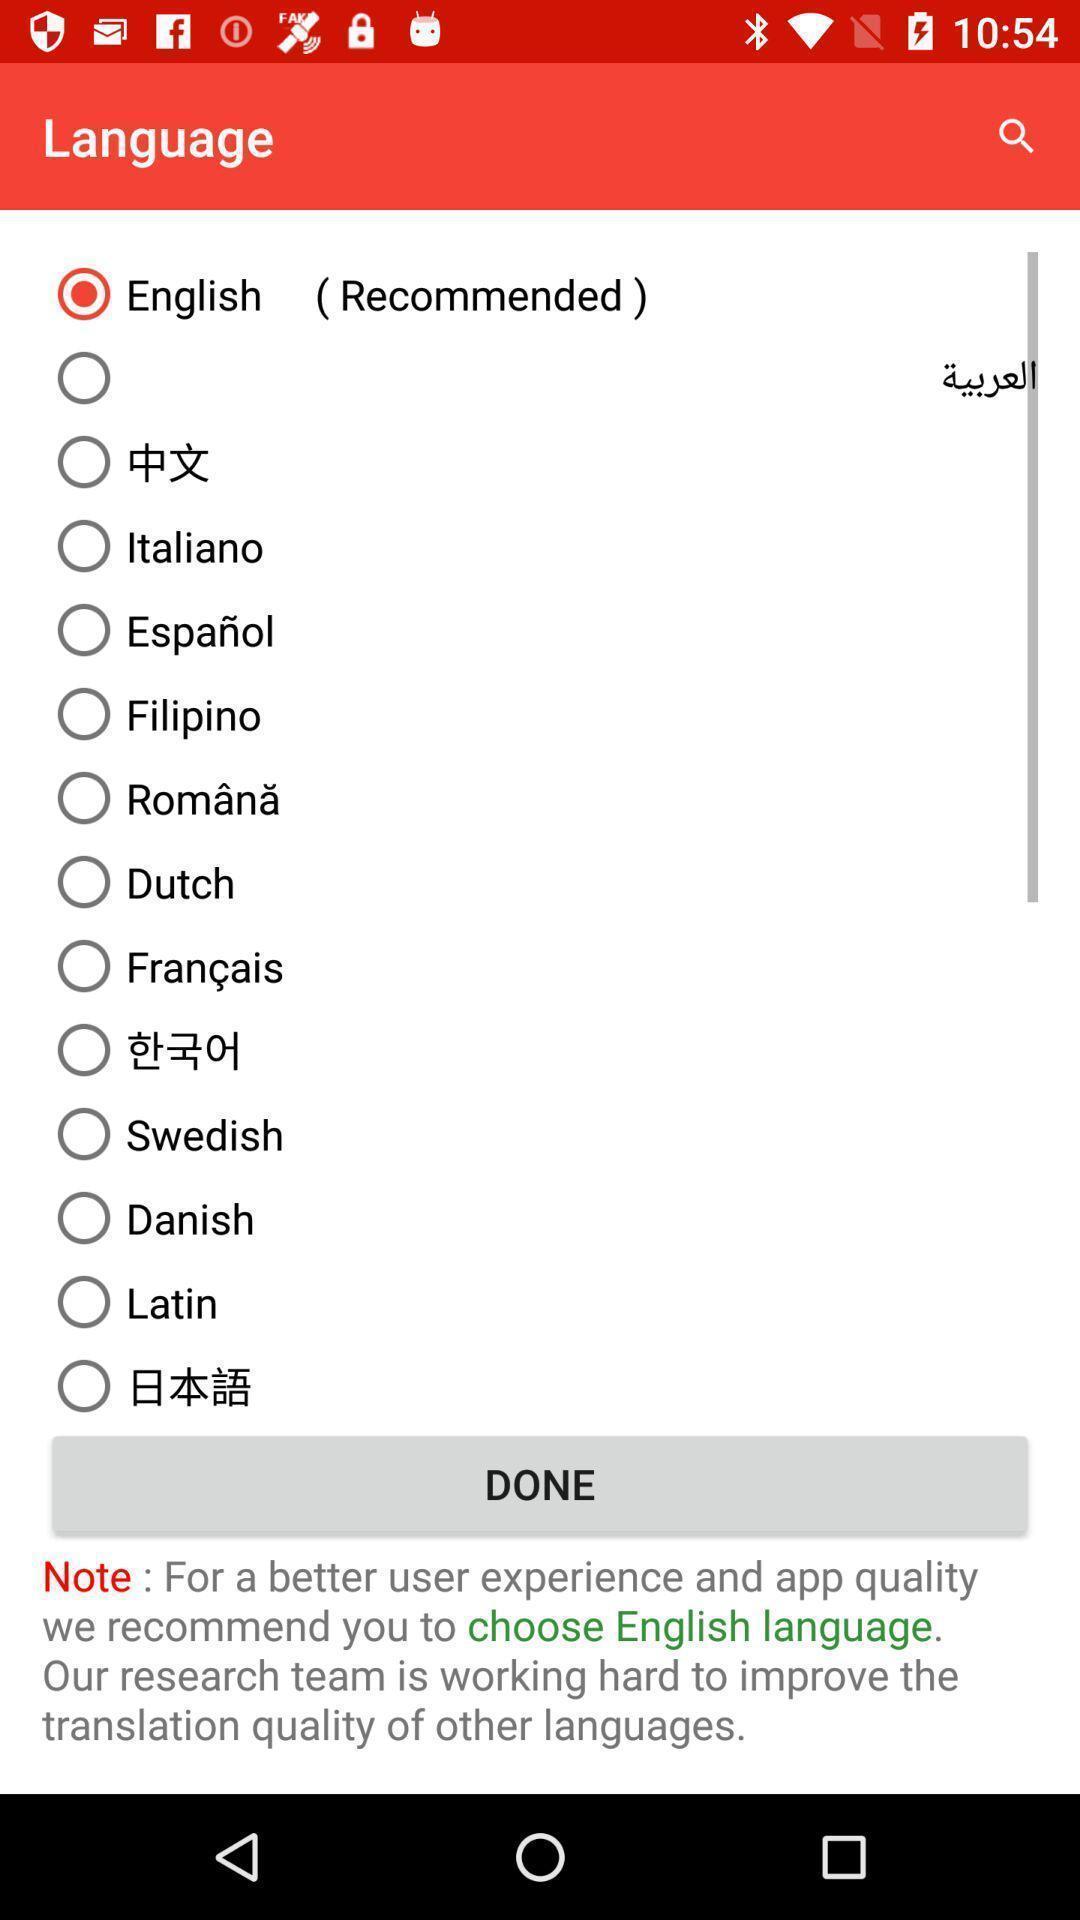Provide a description of this screenshot. Page showing to select language from the list. 